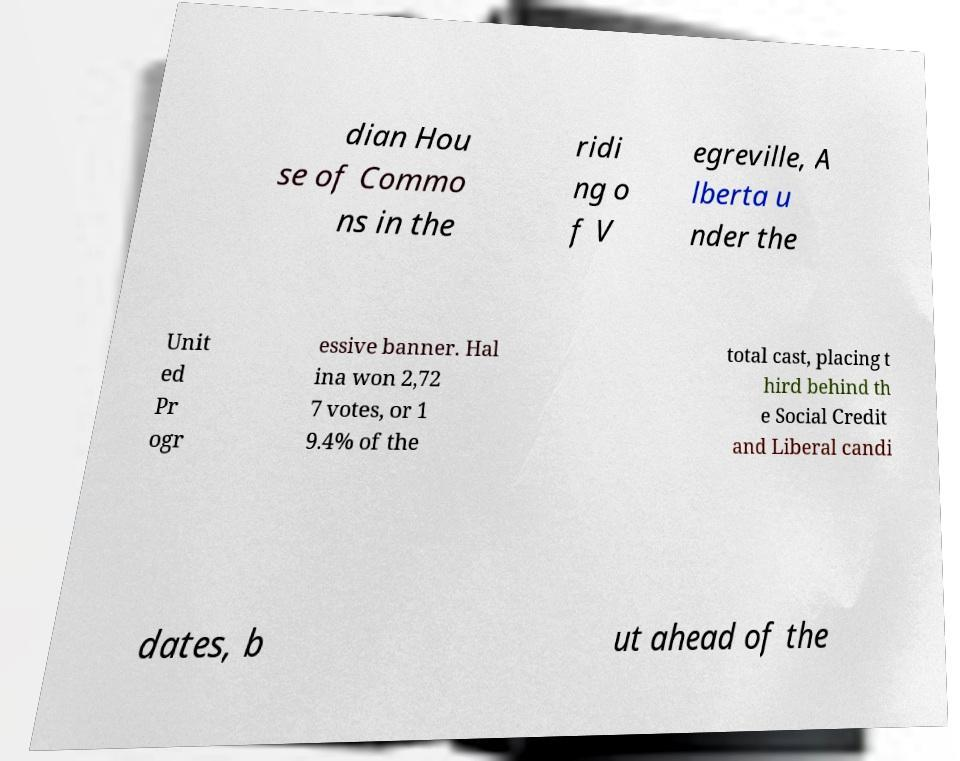I need the written content from this picture converted into text. Can you do that? dian Hou se of Commo ns in the ridi ng o f V egreville, A lberta u nder the Unit ed Pr ogr essive banner. Hal ina won 2,72 7 votes, or 1 9.4% of the total cast, placing t hird behind th e Social Credit and Liberal candi dates, b ut ahead of the 